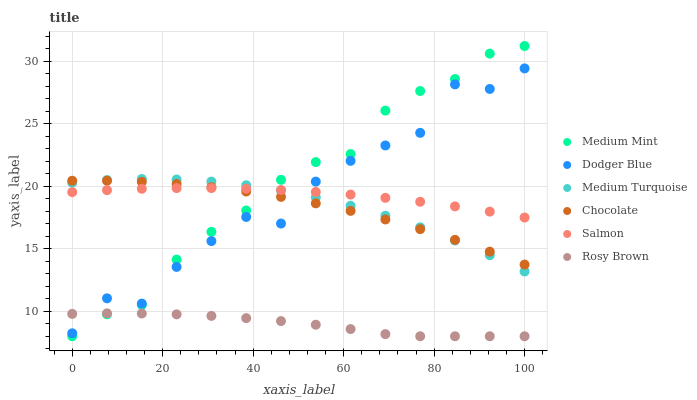Does Rosy Brown have the minimum area under the curve?
Answer yes or no. Yes. Does Medium Mint have the maximum area under the curve?
Answer yes or no. Yes. Does Salmon have the minimum area under the curve?
Answer yes or no. No. Does Salmon have the maximum area under the curve?
Answer yes or no. No. Is Salmon the smoothest?
Answer yes or no. Yes. Is Dodger Blue the roughest?
Answer yes or no. Yes. Is Rosy Brown the smoothest?
Answer yes or no. No. Is Rosy Brown the roughest?
Answer yes or no. No. Does Medium Mint have the lowest value?
Answer yes or no. Yes. Does Salmon have the lowest value?
Answer yes or no. No. Does Medium Mint have the highest value?
Answer yes or no. Yes. Does Salmon have the highest value?
Answer yes or no. No. Is Rosy Brown less than Medium Turquoise?
Answer yes or no. Yes. Is Medium Turquoise greater than Rosy Brown?
Answer yes or no. Yes. Does Rosy Brown intersect Dodger Blue?
Answer yes or no. Yes. Is Rosy Brown less than Dodger Blue?
Answer yes or no. No. Is Rosy Brown greater than Dodger Blue?
Answer yes or no. No. Does Rosy Brown intersect Medium Turquoise?
Answer yes or no. No. 